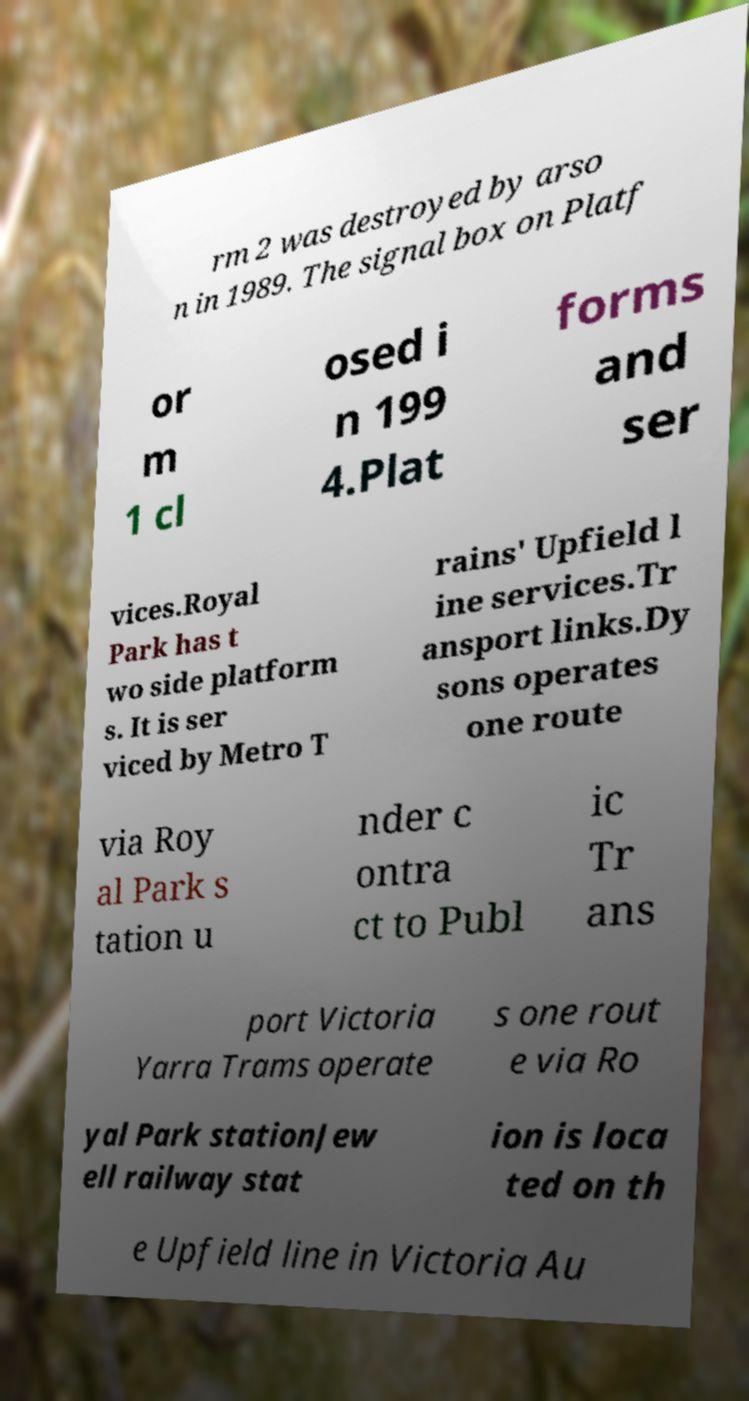Can you accurately transcribe the text from the provided image for me? rm 2 was destroyed by arso n in 1989. The signal box on Platf or m 1 cl osed i n 199 4.Plat forms and ser vices.Royal Park has t wo side platform s. It is ser viced by Metro T rains' Upfield l ine services.Tr ansport links.Dy sons operates one route via Roy al Park s tation u nder c ontra ct to Publ ic Tr ans port Victoria Yarra Trams operate s one rout e via Ro yal Park stationJew ell railway stat ion is loca ted on th e Upfield line in Victoria Au 